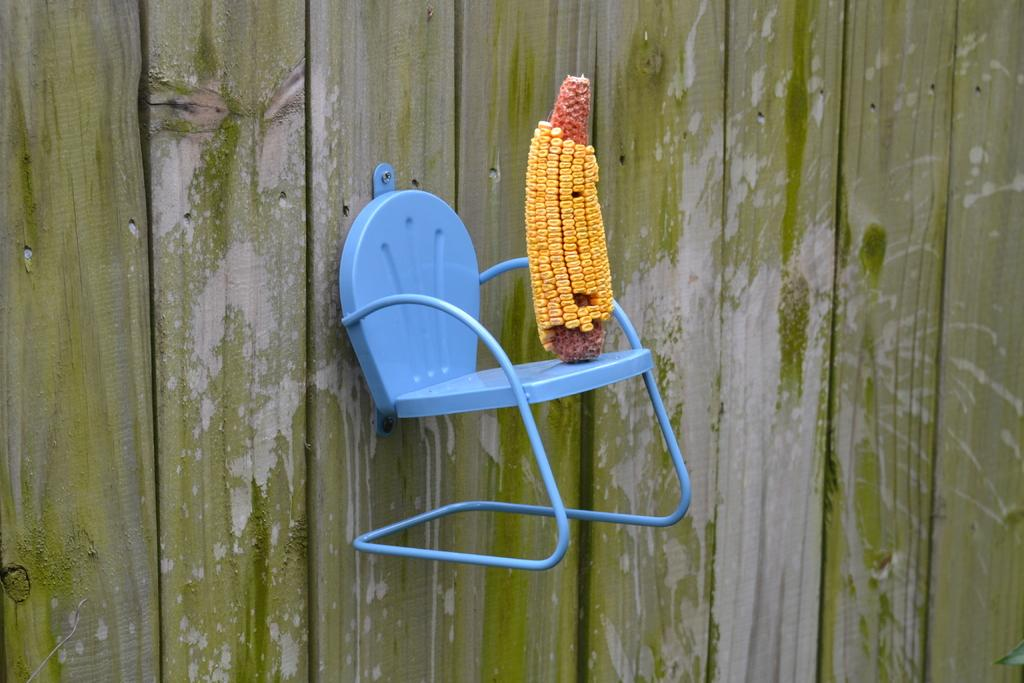What is attached to the wall in the image? There is a small chair fixed to the wall in the image. What is on the chair? There is corn on the chair. What level of humor can be observed in the image? There is no indication of humor in the image; it simply shows a small chair fixed to the wall with corn on it. Is there a button on the chair in the image? There is no button present on the chair in the image. 